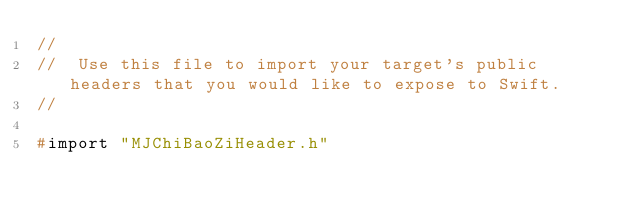Convert code to text. <code><loc_0><loc_0><loc_500><loc_500><_C_>//
//  Use this file to import your target's public headers that you would like to expose to Swift.
//

#import "MJChiBaoZiHeader.h"
</code> 